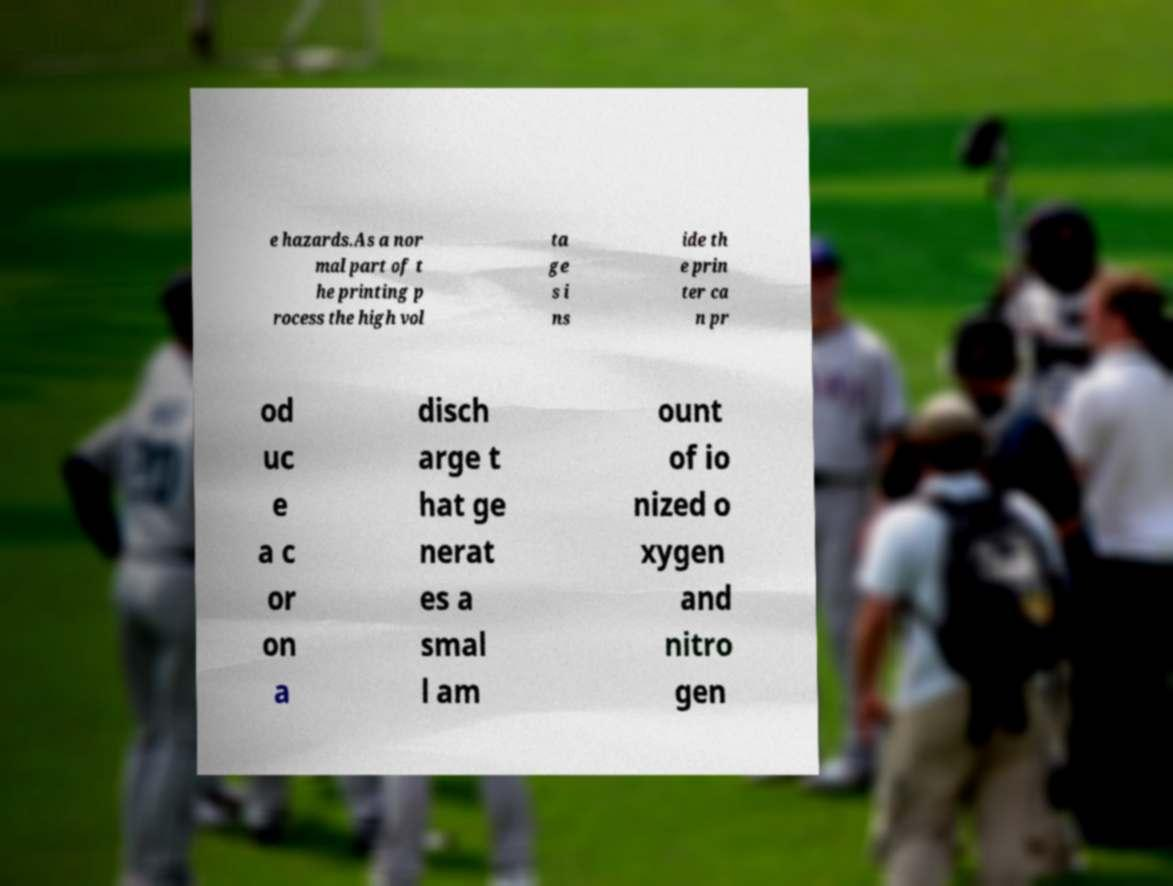Could you extract and type out the text from this image? e hazards.As a nor mal part of t he printing p rocess the high vol ta ge s i ns ide th e prin ter ca n pr od uc e a c or on a disch arge t hat ge nerat es a smal l am ount of io nized o xygen and nitro gen 